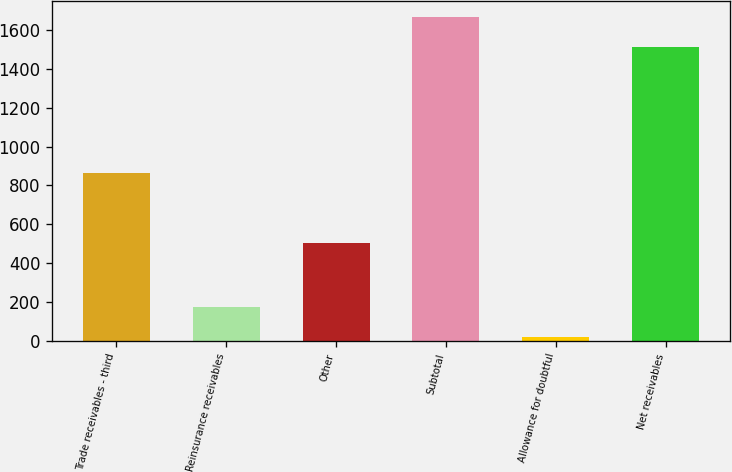Convert chart to OTSL. <chart><loc_0><loc_0><loc_500><loc_500><bar_chart><fcel>Trade receivables - third<fcel>Reinsurance receivables<fcel>Other<fcel>Subtotal<fcel>Allowance for doubtful<fcel>Net receivables<nl><fcel>865<fcel>173.3<fcel>506<fcel>1664.3<fcel>22<fcel>1513<nl></chart> 